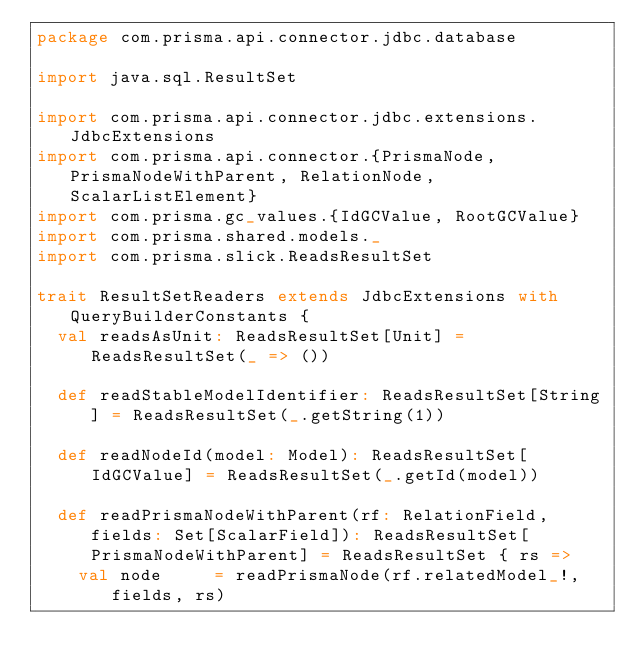<code> <loc_0><loc_0><loc_500><loc_500><_Scala_>package com.prisma.api.connector.jdbc.database

import java.sql.ResultSet

import com.prisma.api.connector.jdbc.extensions.JdbcExtensions
import com.prisma.api.connector.{PrismaNode, PrismaNodeWithParent, RelationNode, ScalarListElement}
import com.prisma.gc_values.{IdGCValue, RootGCValue}
import com.prisma.shared.models._
import com.prisma.slick.ReadsResultSet

trait ResultSetReaders extends JdbcExtensions with QueryBuilderConstants {
  val readsAsUnit: ReadsResultSet[Unit] = ReadsResultSet(_ => ())

  def readStableModelIdentifier: ReadsResultSet[String] = ReadsResultSet(_.getString(1))

  def readNodeId(model: Model): ReadsResultSet[IdGCValue] = ReadsResultSet(_.getId(model))

  def readPrismaNodeWithParent(rf: RelationField, fields: Set[ScalarField]): ReadsResultSet[PrismaNodeWithParent] = ReadsResultSet { rs =>
    val node     = readPrismaNode(rf.relatedModel_!, fields, rs)</code> 